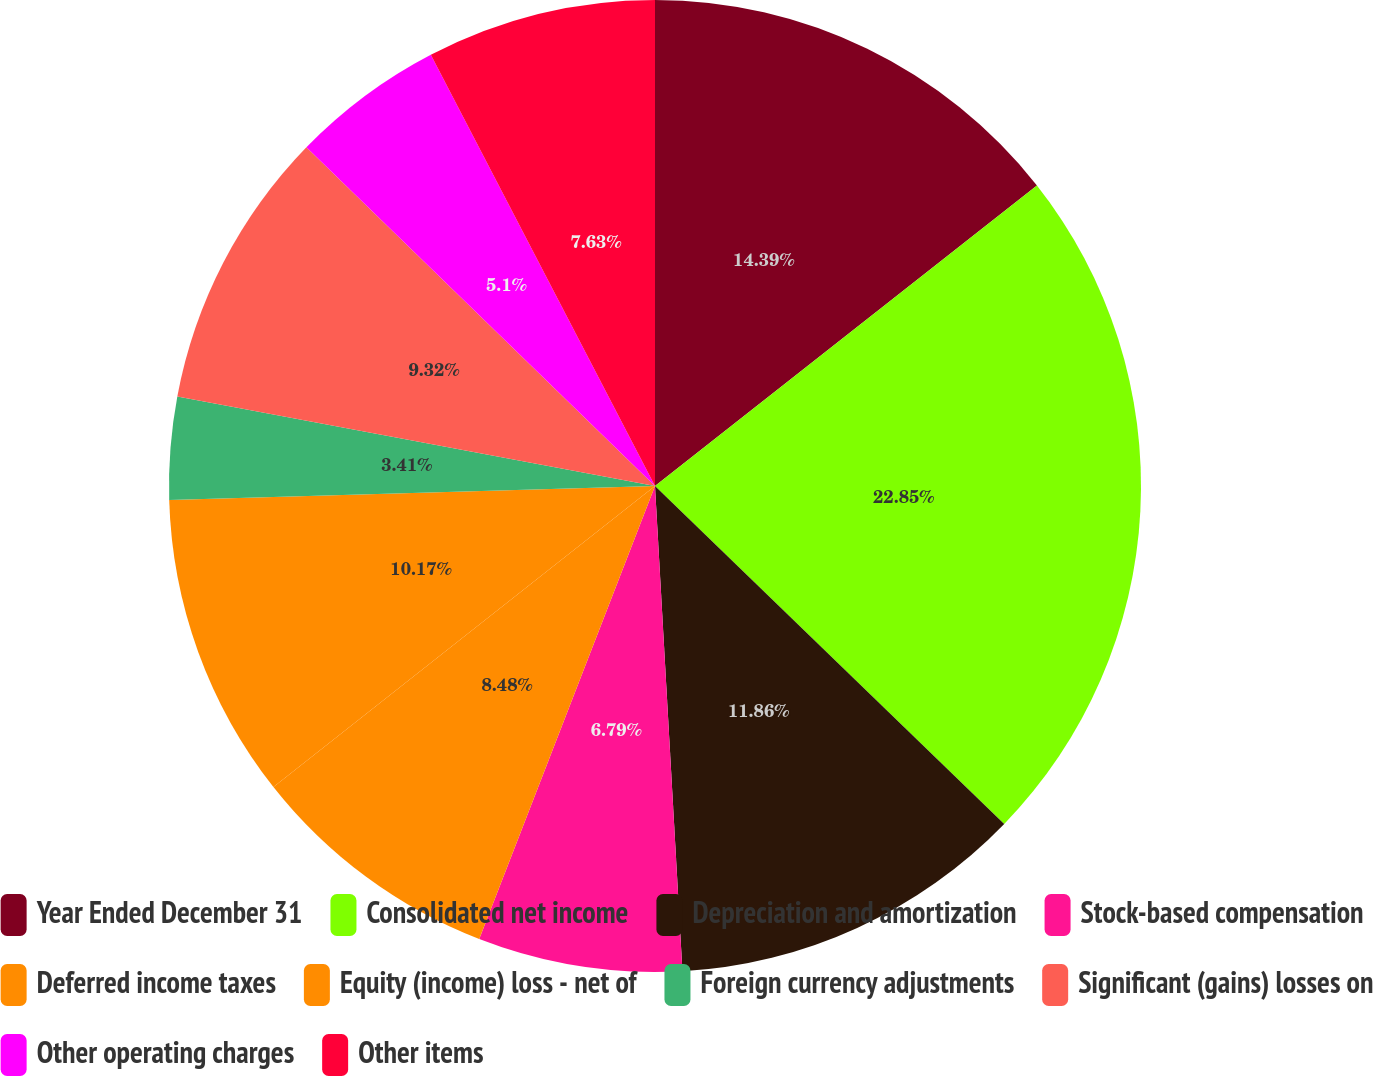<chart> <loc_0><loc_0><loc_500><loc_500><pie_chart><fcel>Year Ended December 31<fcel>Consolidated net income<fcel>Depreciation and amortization<fcel>Stock-based compensation<fcel>Deferred income taxes<fcel>Equity (income) loss - net of<fcel>Foreign currency adjustments<fcel>Significant (gains) losses on<fcel>Other operating charges<fcel>Other items<nl><fcel>14.39%<fcel>22.85%<fcel>11.86%<fcel>6.79%<fcel>8.48%<fcel>10.17%<fcel>3.41%<fcel>9.32%<fcel>5.1%<fcel>7.63%<nl></chart> 